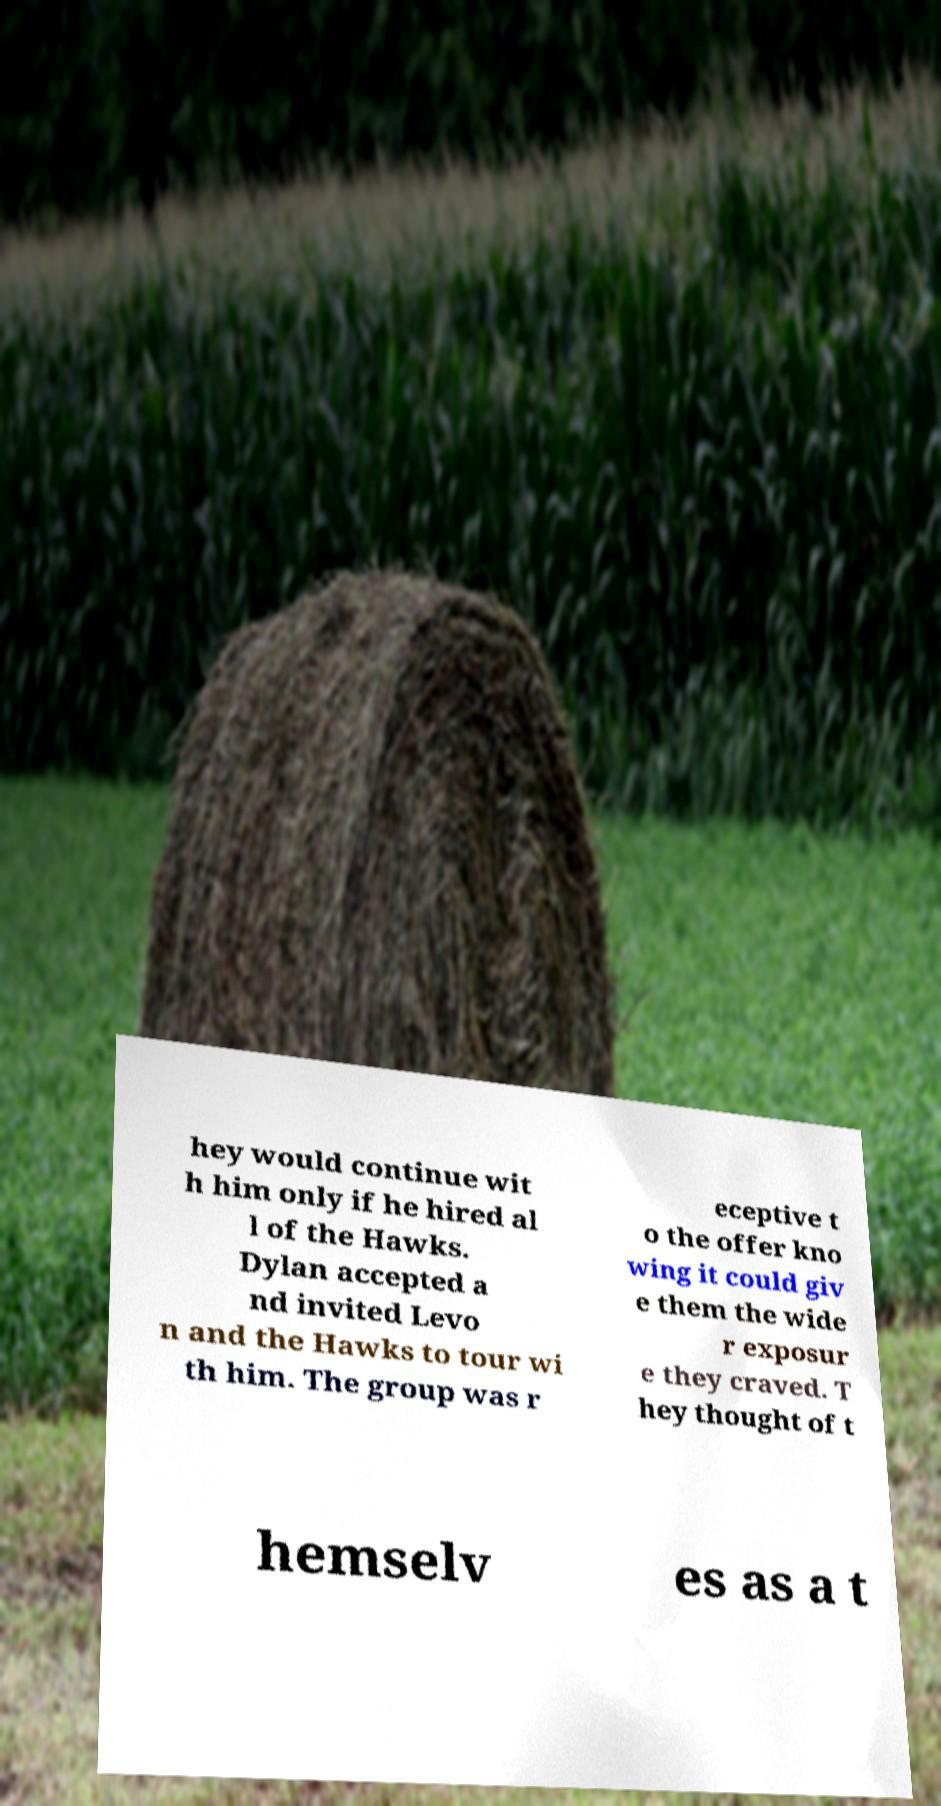Can you accurately transcribe the text from the provided image for me? hey would continue wit h him only if he hired al l of the Hawks. Dylan accepted a nd invited Levo n and the Hawks to tour wi th him. The group was r eceptive t o the offer kno wing it could giv e them the wide r exposur e they craved. T hey thought of t hemselv es as a t 